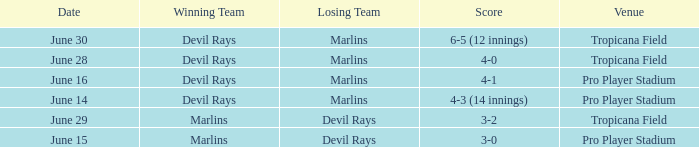Parse the full table. {'header': ['Date', 'Winning Team', 'Losing Team', 'Score', 'Venue'], 'rows': [['June 30', 'Devil Rays', 'Marlins', '6-5 (12 innings)', 'Tropicana Field'], ['June 28', 'Devil Rays', 'Marlins', '4-0', 'Tropicana Field'], ['June 16', 'Devil Rays', 'Marlins', '4-1', 'Pro Player Stadium'], ['June 14', 'Devil Rays', 'Marlins', '4-3 (14 innings)', 'Pro Player Stadium'], ['June 29', 'Marlins', 'Devil Rays', '3-2', 'Tropicana Field'], ['June 15', 'Marlins', 'Devil Rays', '3-0', 'Pro Player Stadium']]} Who won by a score of 4-1? Devil Rays. 